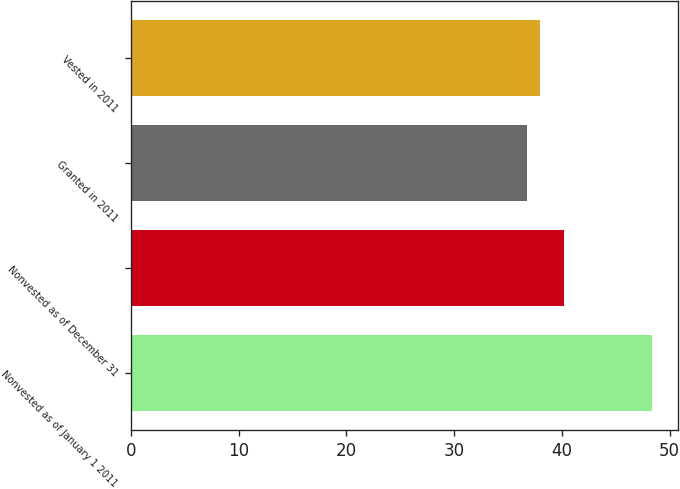Convert chart. <chart><loc_0><loc_0><loc_500><loc_500><bar_chart><fcel>Nonvested as of January 1 2011<fcel>Nonvested as of December 31<fcel>Granted in 2011<fcel>Vested in 2011<nl><fcel>48.4<fcel>40.2<fcel>36.8<fcel>37.96<nl></chart> 